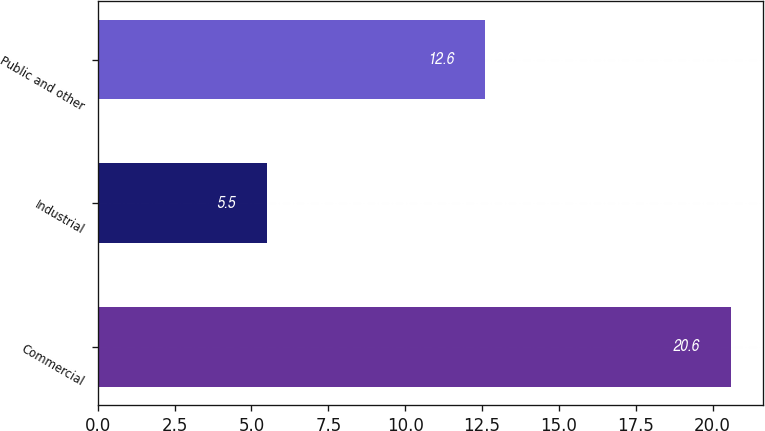Convert chart. <chart><loc_0><loc_0><loc_500><loc_500><bar_chart><fcel>Commercial<fcel>Industrial<fcel>Public and other<nl><fcel>20.6<fcel>5.5<fcel>12.6<nl></chart> 